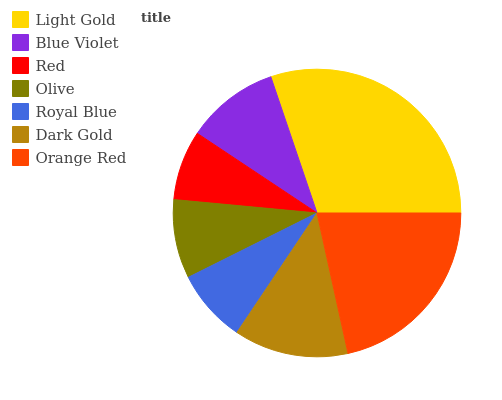Is Red the minimum?
Answer yes or no. Yes. Is Light Gold the maximum?
Answer yes or no. Yes. Is Blue Violet the minimum?
Answer yes or no. No. Is Blue Violet the maximum?
Answer yes or no. No. Is Light Gold greater than Blue Violet?
Answer yes or no. Yes. Is Blue Violet less than Light Gold?
Answer yes or no. Yes. Is Blue Violet greater than Light Gold?
Answer yes or no. No. Is Light Gold less than Blue Violet?
Answer yes or no. No. Is Blue Violet the high median?
Answer yes or no. Yes. Is Blue Violet the low median?
Answer yes or no. Yes. Is Dark Gold the high median?
Answer yes or no. No. Is Dark Gold the low median?
Answer yes or no. No. 